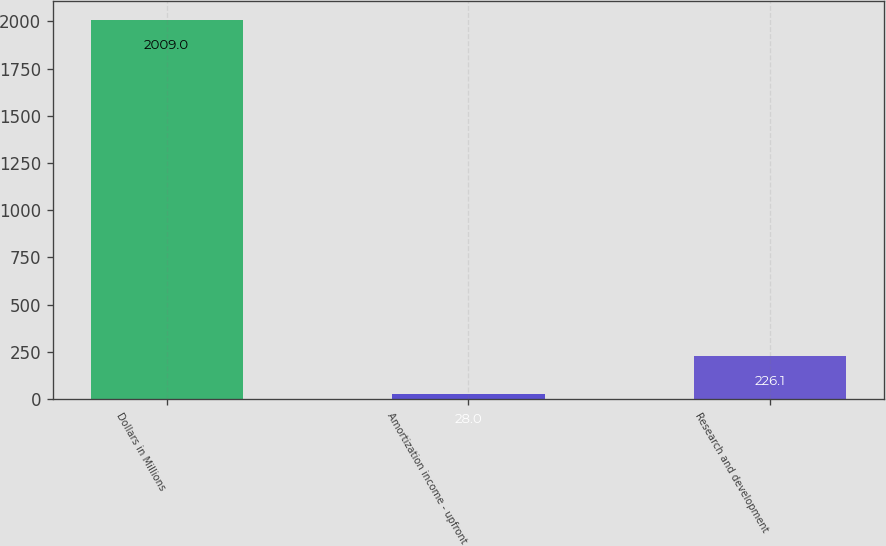Convert chart to OTSL. <chart><loc_0><loc_0><loc_500><loc_500><bar_chart><fcel>Dollars in Millions<fcel>Amortization income - upfront<fcel>Research and development<nl><fcel>2009<fcel>28<fcel>226.1<nl></chart> 